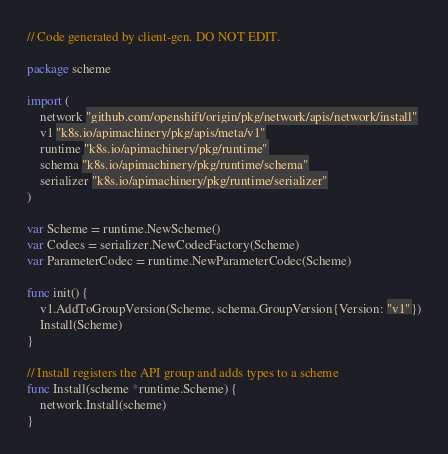<code> <loc_0><loc_0><loc_500><loc_500><_Go_>// Code generated by client-gen. DO NOT EDIT.

package scheme

import (
	network "github.com/openshift/origin/pkg/network/apis/network/install"
	v1 "k8s.io/apimachinery/pkg/apis/meta/v1"
	runtime "k8s.io/apimachinery/pkg/runtime"
	schema "k8s.io/apimachinery/pkg/runtime/schema"
	serializer "k8s.io/apimachinery/pkg/runtime/serializer"
)

var Scheme = runtime.NewScheme()
var Codecs = serializer.NewCodecFactory(Scheme)
var ParameterCodec = runtime.NewParameterCodec(Scheme)

func init() {
	v1.AddToGroupVersion(Scheme, schema.GroupVersion{Version: "v1"})
	Install(Scheme)
}

// Install registers the API group and adds types to a scheme
func Install(scheme *runtime.Scheme) {
	network.Install(scheme)
}
</code> 